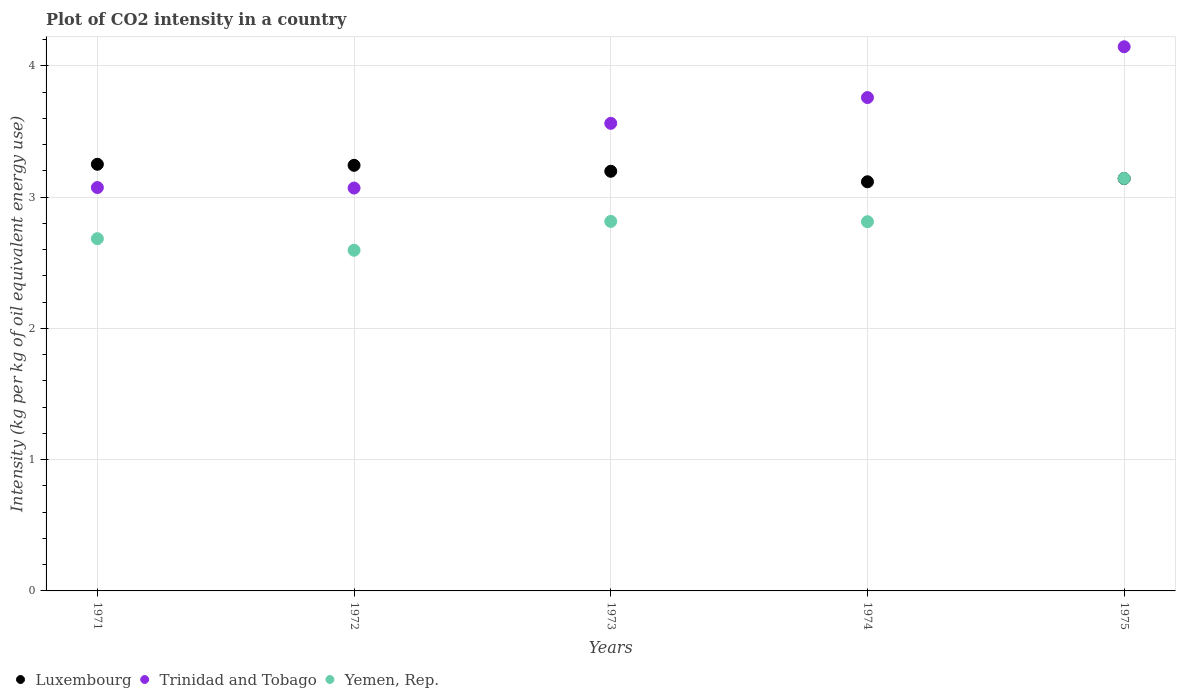How many different coloured dotlines are there?
Your answer should be compact. 3. Is the number of dotlines equal to the number of legend labels?
Make the answer very short. Yes. What is the CO2 intensity in in Yemen, Rep. in 1974?
Your response must be concise. 2.81. Across all years, what is the maximum CO2 intensity in in Trinidad and Tobago?
Offer a very short reply. 4.15. Across all years, what is the minimum CO2 intensity in in Luxembourg?
Offer a very short reply. 3.12. In which year was the CO2 intensity in in Luxembourg maximum?
Provide a succinct answer. 1971. In which year was the CO2 intensity in in Luxembourg minimum?
Provide a succinct answer. 1974. What is the total CO2 intensity in in Yemen, Rep. in the graph?
Provide a short and direct response. 14.05. What is the difference between the CO2 intensity in in Luxembourg in 1972 and that in 1975?
Provide a short and direct response. 0.1. What is the difference between the CO2 intensity in in Trinidad and Tobago in 1973 and the CO2 intensity in in Yemen, Rep. in 1972?
Make the answer very short. 0.97. What is the average CO2 intensity in in Luxembourg per year?
Keep it short and to the point. 3.19. In the year 1973, what is the difference between the CO2 intensity in in Trinidad and Tobago and CO2 intensity in in Luxembourg?
Make the answer very short. 0.37. In how many years, is the CO2 intensity in in Trinidad and Tobago greater than 3 kg?
Offer a terse response. 5. What is the ratio of the CO2 intensity in in Luxembourg in 1973 to that in 1974?
Keep it short and to the point. 1.03. What is the difference between the highest and the second highest CO2 intensity in in Trinidad and Tobago?
Provide a short and direct response. 0.39. What is the difference between the highest and the lowest CO2 intensity in in Yemen, Rep.?
Your answer should be very brief. 0.55. In how many years, is the CO2 intensity in in Luxembourg greater than the average CO2 intensity in in Luxembourg taken over all years?
Keep it short and to the point. 3. Does the CO2 intensity in in Trinidad and Tobago monotonically increase over the years?
Offer a terse response. No. What is the difference between two consecutive major ticks on the Y-axis?
Keep it short and to the point. 1. Are the values on the major ticks of Y-axis written in scientific E-notation?
Offer a terse response. No. Does the graph contain grids?
Provide a short and direct response. Yes. Where does the legend appear in the graph?
Give a very brief answer. Bottom left. How are the legend labels stacked?
Give a very brief answer. Horizontal. What is the title of the graph?
Your answer should be very brief. Plot of CO2 intensity in a country. What is the label or title of the X-axis?
Keep it short and to the point. Years. What is the label or title of the Y-axis?
Provide a short and direct response. Intensity (kg per kg of oil equivalent energy use). What is the Intensity (kg per kg of oil equivalent energy use) in Luxembourg in 1971?
Keep it short and to the point. 3.25. What is the Intensity (kg per kg of oil equivalent energy use) of Trinidad and Tobago in 1971?
Provide a short and direct response. 3.07. What is the Intensity (kg per kg of oil equivalent energy use) of Yemen, Rep. in 1971?
Offer a terse response. 2.68. What is the Intensity (kg per kg of oil equivalent energy use) in Luxembourg in 1972?
Your answer should be very brief. 3.24. What is the Intensity (kg per kg of oil equivalent energy use) of Trinidad and Tobago in 1972?
Give a very brief answer. 3.07. What is the Intensity (kg per kg of oil equivalent energy use) in Yemen, Rep. in 1972?
Provide a short and direct response. 2.6. What is the Intensity (kg per kg of oil equivalent energy use) in Luxembourg in 1973?
Make the answer very short. 3.2. What is the Intensity (kg per kg of oil equivalent energy use) in Trinidad and Tobago in 1973?
Offer a very short reply. 3.56. What is the Intensity (kg per kg of oil equivalent energy use) in Yemen, Rep. in 1973?
Keep it short and to the point. 2.81. What is the Intensity (kg per kg of oil equivalent energy use) in Luxembourg in 1974?
Ensure brevity in your answer.  3.12. What is the Intensity (kg per kg of oil equivalent energy use) of Trinidad and Tobago in 1974?
Your response must be concise. 3.76. What is the Intensity (kg per kg of oil equivalent energy use) in Yemen, Rep. in 1974?
Your answer should be very brief. 2.81. What is the Intensity (kg per kg of oil equivalent energy use) in Luxembourg in 1975?
Provide a short and direct response. 3.14. What is the Intensity (kg per kg of oil equivalent energy use) in Trinidad and Tobago in 1975?
Your response must be concise. 4.15. What is the Intensity (kg per kg of oil equivalent energy use) in Yemen, Rep. in 1975?
Your answer should be very brief. 3.14. Across all years, what is the maximum Intensity (kg per kg of oil equivalent energy use) of Luxembourg?
Your answer should be very brief. 3.25. Across all years, what is the maximum Intensity (kg per kg of oil equivalent energy use) in Trinidad and Tobago?
Offer a terse response. 4.15. Across all years, what is the maximum Intensity (kg per kg of oil equivalent energy use) of Yemen, Rep.?
Provide a short and direct response. 3.14. Across all years, what is the minimum Intensity (kg per kg of oil equivalent energy use) in Luxembourg?
Your response must be concise. 3.12. Across all years, what is the minimum Intensity (kg per kg of oil equivalent energy use) in Trinidad and Tobago?
Your answer should be very brief. 3.07. Across all years, what is the minimum Intensity (kg per kg of oil equivalent energy use) of Yemen, Rep.?
Make the answer very short. 2.6. What is the total Intensity (kg per kg of oil equivalent energy use) of Luxembourg in the graph?
Offer a terse response. 15.95. What is the total Intensity (kg per kg of oil equivalent energy use) in Trinidad and Tobago in the graph?
Your answer should be compact. 17.61. What is the total Intensity (kg per kg of oil equivalent energy use) in Yemen, Rep. in the graph?
Keep it short and to the point. 14.05. What is the difference between the Intensity (kg per kg of oil equivalent energy use) of Luxembourg in 1971 and that in 1972?
Give a very brief answer. 0.01. What is the difference between the Intensity (kg per kg of oil equivalent energy use) in Trinidad and Tobago in 1971 and that in 1972?
Your response must be concise. 0. What is the difference between the Intensity (kg per kg of oil equivalent energy use) in Yemen, Rep. in 1971 and that in 1972?
Keep it short and to the point. 0.09. What is the difference between the Intensity (kg per kg of oil equivalent energy use) of Luxembourg in 1971 and that in 1973?
Your response must be concise. 0.05. What is the difference between the Intensity (kg per kg of oil equivalent energy use) in Trinidad and Tobago in 1971 and that in 1973?
Give a very brief answer. -0.49. What is the difference between the Intensity (kg per kg of oil equivalent energy use) of Yemen, Rep. in 1971 and that in 1973?
Your answer should be compact. -0.13. What is the difference between the Intensity (kg per kg of oil equivalent energy use) in Luxembourg in 1971 and that in 1974?
Make the answer very short. 0.13. What is the difference between the Intensity (kg per kg of oil equivalent energy use) in Trinidad and Tobago in 1971 and that in 1974?
Offer a terse response. -0.69. What is the difference between the Intensity (kg per kg of oil equivalent energy use) in Yemen, Rep. in 1971 and that in 1974?
Keep it short and to the point. -0.13. What is the difference between the Intensity (kg per kg of oil equivalent energy use) in Luxembourg in 1971 and that in 1975?
Offer a terse response. 0.11. What is the difference between the Intensity (kg per kg of oil equivalent energy use) of Trinidad and Tobago in 1971 and that in 1975?
Make the answer very short. -1.07. What is the difference between the Intensity (kg per kg of oil equivalent energy use) of Yemen, Rep. in 1971 and that in 1975?
Ensure brevity in your answer.  -0.46. What is the difference between the Intensity (kg per kg of oil equivalent energy use) of Luxembourg in 1972 and that in 1973?
Give a very brief answer. 0.05. What is the difference between the Intensity (kg per kg of oil equivalent energy use) in Trinidad and Tobago in 1972 and that in 1973?
Offer a terse response. -0.49. What is the difference between the Intensity (kg per kg of oil equivalent energy use) in Yemen, Rep. in 1972 and that in 1973?
Your answer should be very brief. -0.22. What is the difference between the Intensity (kg per kg of oil equivalent energy use) of Luxembourg in 1972 and that in 1974?
Provide a short and direct response. 0.13. What is the difference between the Intensity (kg per kg of oil equivalent energy use) of Trinidad and Tobago in 1972 and that in 1974?
Ensure brevity in your answer.  -0.69. What is the difference between the Intensity (kg per kg of oil equivalent energy use) in Yemen, Rep. in 1972 and that in 1974?
Your response must be concise. -0.22. What is the difference between the Intensity (kg per kg of oil equivalent energy use) in Luxembourg in 1972 and that in 1975?
Your response must be concise. 0.1. What is the difference between the Intensity (kg per kg of oil equivalent energy use) of Trinidad and Tobago in 1972 and that in 1975?
Ensure brevity in your answer.  -1.08. What is the difference between the Intensity (kg per kg of oil equivalent energy use) of Yemen, Rep. in 1972 and that in 1975?
Keep it short and to the point. -0.55. What is the difference between the Intensity (kg per kg of oil equivalent energy use) in Trinidad and Tobago in 1973 and that in 1974?
Provide a succinct answer. -0.2. What is the difference between the Intensity (kg per kg of oil equivalent energy use) in Yemen, Rep. in 1973 and that in 1974?
Your answer should be compact. 0. What is the difference between the Intensity (kg per kg of oil equivalent energy use) of Luxembourg in 1973 and that in 1975?
Your answer should be compact. 0.06. What is the difference between the Intensity (kg per kg of oil equivalent energy use) in Trinidad and Tobago in 1973 and that in 1975?
Offer a very short reply. -0.58. What is the difference between the Intensity (kg per kg of oil equivalent energy use) in Yemen, Rep. in 1973 and that in 1975?
Offer a very short reply. -0.33. What is the difference between the Intensity (kg per kg of oil equivalent energy use) in Luxembourg in 1974 and that in 1975?
Your answer should be compact. -0.02. What is the difference between the Intensity (kg per kg of oil equivalent energy use) in Trinidad and Tobago in 1974 and that in 1975?
Offer a very short reply. -0.39. What is the difference between the Intensity (kg per kg of oil equivalent energy use) of Yemen, Rep. in 1974 and that in 1975?
Your answer should be very brief. -0.33. What is the difference between the Intensity (kg per kg of oil equivalent energy use) of Luxembourg in 1971 and the Intensity (kg per kg of oil equivalent energy use) of Trinidad and Tobago in 1972?
Ensure brevity in your answer.  0.18. What is the difference between the Intensity (kg per kg of oil equivalent energy use) of Luxembourg in 1971 and the Intensity (kg per kg of oil equivalent energy use) of Yemen, Rep. in 1972?
Provide a short and direct response. 0.65. What is the difference between the Intensity (kg per kg of oil equivalent energy use) in Trinidad and Tobago in 1971 and the Intensity (kg per kg of oil equivalent energy use) in Yemen, Rep. in 1972?
Make the answer very short. 0.48. What is the difference between the Intensity (kg per kg of oil equivalent energy use) of Luxembourg in 1971 and the Intensity (kg per kg of oil equivalent energy use) of Trinidad and Tobago in 1973?
Make the answer very short. -0.31. What is the difference between the Intensity (kg per kg of oil equivalent energy use) in Luxembourg in 1971 and the Intensity (kg per kg of oil equivalent energy use) in Yemen, Rep. in 1973?
Your answer should be compact. 0.44. What is the difference between the Intensity (kg per kg of oil equivalent energy use) of Trinidad and Tobago in 1971 and the Intensity (kg per kg of oil equivalent energy use) of Yemen, Rep. in 1973?
Give a very brief answer. 0.26. What is the difference between the Intensity (kg per kg of oil equivalent energy use) of Luxembourg in 1971 and the Intensity (kg per kg of oil equivalent energy use) of Trinidad and Tobago in 1974?
Make the answer very short. -0.51. What is the difference between the Intensity (kg per kg of oil equivalent energy use) in Luxembourg in 1971 and the Intensity (kg per kg of oil equivalent energy use) in Yemen, Rep. in 1974?
Ensure brevity in your answer.  0.44. What is the difference between the Intensity (kg per kg of oil equivalent energy use) of Trinidad and Tobago in 1971 and the Intensity (kg per kg of oil equivalent energy use) of Yemen, Rep. in 1974?
Your response must be concise. 0.26. What is the difference between the Intensity (kg per kg of oil equivalent energy use) in Luxembourg in 1971 and the Intensity (kg per kg of oil equivalent energy use) in Trinidad and Tobago in 1975?
Provide a succinct answer. -0.9. What is the difference between the Intensity (kg per kg of oil equivalent energy use) of Luxembourg in 1971 and the Intensity (kg per kg of oil equivalent energy use) of Yemen, Rep. in 1975?
Your answer should be very brief. 0.11. What is the difference between the Intensity (kg per kg of oil equivalent energy use) of Trinidad and Tobago in 1971 and the Intensity (kg per kg of oil equivalent energy use) of Yemen, Rep. in 1975?
Make the answer very short. -0.07. What is the difference between the Intensity (kg per kg of oil equivalent energy use) of Luxembourg in 1972 and the Intensity (kg per kg of oil equivalent energy use) of Trinidad and Tobago in 1973?
Offer a terse response. -0.32. What is the difference between the Intensity (kg per kg of oil equivalent energy use) of Luxembourg in 1972 and the Intensity (kg per kg of oil equivalent energy use) of Yemen, Rep. in 1973?
Provide a short and direct response. 0.43. What is the difference between the Intensity (kg per kg of oil equivalent energy use) in Trinidad and Tobago in 1972 and the Intensity (kg per kg of oil equivalent energy use) in Yemen, Rep. in 1973?
Ensure brevity in your answer.  0.25. What is the difference between the Intensity (kg per kg of oil equivalent energy use) of Luxembourg in 1972 and the Intensity (kg per kg of oil equivalent energy use) of Trinidad and Tobago in 1974?
Ensure brevity in your answer.  -0.52. What is the difference between the Intensity (kg per kg of oil equivalent energy use) in Luxembourg in 1972 and the Intensity (kg per kg of oil equivalent energy use) in Yemen, Rep. in 1974?
Offer a very short reply. 0.43. What is the difference between the Intensity (kg per kg of oil equivalent energy use) in Trinidad and Tobago in 1972 and the Intensity (kg per kg of oil equivalent energy use) in Yemen, Rep. in 1974?
Your answer should be very brief. 0.26. What is the difference between the Intensity (kg per kg of oil equivalent energy use) in Luxembourg in 1972 and the Intensity (kg per kg of oil equivalent energy use) in Trinidad and Tobago in 1975?
Make the answer very short. -0.9. What is the difference between the Intensity (kg per kg of oil equivalent energy use) of Luxembourg in 1972 and the Intensity (kg per kg of oil equivalent energy use) of Yemen, Rep. in 1975?
Keep it short and to the point. 0.1. What is the difference between the Intensity (kg per kg of oil equivalent energy use) of Trinidad and Tobago in 1972 and the Intensity (kg per kg of oil equivalent energy use) of Yemen, Rep. in 1975?
Give a very brief answer. -0.07. What is the difference between the Intensity (kg per kg of oil equivalent energy use) in Luxembourg in 1973 and the Intensity (kg per kg of oil equivalent energy use) in Trinidad and Tobago in 1974?
Ensure brevity in your answer.  -0.56. What is the difference between the Intensity (kg per kg of oil equivalent energy use) in Luxembourg in 1973 and the Intensity (kg per kg of oil equivalent energy use) in Yemen, Rep. in 1974?
Give a very brief answer. 0.38. What is the difference between the Intensity (kg per kg of oil equivalent energy use) in Trinidad and Tobago in 1973 and the Intensity (kg per kg of oil equivalent energy use) in Yemen, Rep. in 1974?
Ensure brevity in your answer.  0.75. What is the difference between the Intensity (kg per kg of oil equivalent energy use) of Luxembourg in 1973 and the Intensity (kg per kg of oil equivalent energy use) of Trinidad and Tobago in 1975?
Your answer should be compact. -0.95. What is the difference between the Intensity (kg per kg of oil equivalent energy use) in Luxembourg in 1973 and the Intensity (kg per kg of oil equivalent energy use) in Yemen, Rep. in 1975?
Give a very brief answer. 0.05. What is the difference between the Intensity (kg per kg of oil equivalent energy use) in Trinidad and Tobago in 1973 and the Intensity (kg per kg of oil equivalent energy use) in Yemen, Rep. in 1975?
Provide a short and direct response. 0.42. What is the difference between the Intensity (kg per kg of oil equivalent energy use) of Luxembourg in 1974 and the Intensity (kg per kg of oil equivalent energy use) of Trinidad and Tobago in 1975?
Give a very brief answer. -1.03. What is the difference between the Intensity (kg per kg of oil equivalent energy use) of Luxembourg in 1974 and the Intensity (kg per kg of oil equivalent energy use) of Yemen, Rep. in 1975?
Provide a short and direct response. -0.03. What is the difference between the Intensity (kg per kg of oil equivalent energy use) in Trinidad and Tobago in 1974 and the Intensity (kg per kg of oil equivalent energy use) in Yemen, Rep. in 1975?
Your answer should be very brief. 0.62. What is the average Intensity (kg per kg of oil equivalent energy use) in Luxembourg per year?
Give a very brief answer. 3.19. What is the average Intensity (kg per kg of oil equivalent energy use) in Trinidad and Tobago per year?
Provide a short and direct response. 3.52. What is the average Intensity (kg per kg of oil equivalent energy use) in Yemen, Rep. per year?
Make the answer very short. 2.81. In the year 1971, what is the difference between the Intensity (kg per kg of oil equivalent energy use) of Luxembourg and Intensity (kg per kg of oil equivalent energy use) of Trinidad and Tobago?
Provide a succinct answer. 0.18. In the year 1971, what is the difference between the Intensity (kg per kg of oil equivalent energy use) of Luxembourg and Intensity (kg per kg of oil equivalent energy use) of Yemen, Rep.?
Keep it short and to the point. 0.57. In the year 1971, what is the difference between the Intensity (kg per kg of oil equivalent energy use) in Trinidad and Tobago and Intensity (kg per kg of oil equivalent energy use) in Yemen, Rep.?
Provide a succinct answer. 0.39. In the year 1972, what is the difference between the Intensity (kg per kg of oil equivalent energy use) in Luxembourg and Intensity (kg per kg of oil equivalent energy use) in Trinidad and Tobago?
Your answer should be very brief. 0.17. In the year 1972, what is the difference between the Intensity (kg per kg of oil equivalent energy use) in Luxembourg and Intensity (kg per kg of oil equivalent energy use) in Yemen, Rep.?
Your answer should be compact. 0.65. In the year 1972, what is the difference between the Intensity (kg per kg of oil equivalent energy use) of Trinidad and Tobago and Intensity (kg per kg of oil equivalent energy use) of Yemen, Rep.?
Keep it short and to the point. 0.47. In the year 1973, what is the difference between the Intensity (kg per kg of oil equivalent energy use) of Luxembourg and Intensity (kg per kg of oil equivalent energy use) of Trinidad and Tobago?
Your answer should be compact. -0.37. In the year 1973, what is the difference between the Intensity (kg per kg of oil equivalent energy use) of Luxembourg and Intensity (kg per kg of oil equivalent energy use) of Yemen, Rep.?
Provide a short and direct response. 0.38. In the year 1973, what is the difference between the Intensity (kg per kg of oil equivalent energy use) in Trinidad and Tobago and Intensity (kg per kg of oil equivalent energy use) in Yemen, Rep.?
Make the answer very short. 0.75. In the year 1974, what is the difference between the Intensity (kg per kg of oil equivalent energy use) in Luxembourg and Intensity (kg per kg of oil equivalent energy use) in Trinidad and Tobago?
Provide a short and direct response. -0.64. In the year 1974, what is the difference between the Intensity (kg per kg of oil equivalent energy use) of Luxembourg and Intensity (kg per kg of oil equivalent energy use) of Yemen, Rep.?
Keep it short and to the point. 0.3. In the year 1974, what is the difference between the Intensity (kg per kg of oil equivalent energy use) of Trinidad and Tobago and Intensity (kg per kg of oil equivalent energy use) of Yemen, Rep.?
Offer a terse response. 0.95. In the year 1975, what is the difference between the Intensity (kg per kg of oil equivalent energy use) of Luxembourg and Intensity (kg per kg of oil equivalent energy use) of Trinidad and Tobago?
Offer a terse response. -1. In the year 1975, what is the difference between the Intensity (kg per kg of oil equivalent energy use) of Luxembourg and Intensity (kg per kg of oil equivalent energy use) of Yemen, Rep.?
Make the answer very short. -0. What is the ratio of the Intensity (kg per kg of oil equivalent energy use) of Yemen, Rep. in 1971 to that in 1972?
Ensure brevity in your answer.  1.03. What is the ratio of the Intensity (kg per kg of oil equivalent energy use) in Luxembourg in 1971 to that in 1973?
Your answer should be compact. 1.02. What is the ratio of the Intensity (kg per kg of oil equivalent energy use) of Trinidad and Tobago in 1971 to that in 1973?
Ensure brevity in your answer.  0.86. What is the ratio of the Intensity (kg per kg of oil equivalent energy use) in Yemen, Rep. in 1971 to that in 1973?
Give a very brief answer. 0.95. What is the ratio of the Intensity (kg per kg of oil equivalent energy use) of Luxembourg in 1971 to that in 1974?
Offer a very short reply. 1.04. What is the ratio of the Intensity (kg per kg of oil equivalent energy use) in Trinidad and Tobago in 1971 to that in 1974?
Offer a terse response. 0.82. What is the ratio of the Intensity (kg per kg of oil equivalent energy use) in Yemen, Rep. in 1971 to that in 1974?
Provide a succinct answer. 0.95. What is the ratio of the Intensity (kg per kg of oil equivalent energy use) of Luxembourg in 1971 to that in 1975?
Ensure brevity in your answer.  1.03. What is the ratio of the Intensity (kg per kg of oil equivalent energy use) of Trinidad and Tobago in 1971 to that in 1975?
Provide a short and direct response. 0.74. What is the ratio of the Intensity (kg per kg of oil equivalent energy use) of Yemen, Rep. in 1971 to that in 1975?
Keep it short and to the point. 0.85. What is the ratio of the Intensity (kg per kg of oil equivalent energy use) in Luxembourg in 1972 to that in 1973?
Provide a short and direct response. 1.01. What is the ratio of the Intensity (kg per kg of oil equivalent energy use) of Trinidad and Tobago in 1972 to that in 1973?
Provide a succinct answer. 0.86. What is the ratio of the Intensity (kg per kg of oil equivalent energy use) in Yemen, Rep. in 1972 to that in 1973?
Your response must be concise. 0.92. What is the ratio of the Intensity (kg per kg of oil equivalent energy use) in Luxembourg in 1972 to that in 1974?
Offer a very short reply. 1.04. What is the ratio of the Intensity (kg per kg of oil equivalent energy use) in Trinidad and Tobago in 1972 to that in 1974?
Your answer should be compact. 0.82. What is the ratio of the Intensity (kg per kg of oil equivalent energy use) of Yemen, Rep. in 1972 to that in 1974?
Make the answer very short. 0.92. What is the ratio of the Intensity (kg per kg of oil equivalent energy use) of Luxembourg in 1972 to that in 1975?
Provide a succinct answer. 1.03. What is the ratio of the Intensity (kg per kg of oil equivalent energy use) in Trinidad and Tobago in 1972 to that in 1975?
Provide a short and direct response. 0.74. What is the ratio of the Intensity (kg per kg of oil equivalent energy use) in Yemen, Rep. in 1972 to that in 1975?
Offer a very short reply. 0.83. What is the ratio of the Intensity (kg per kg of oil equivalent energy use) in Luxembourg in 1973 to that in 1974?
Keep it short and to the point. 1.03. What is the ratio of the Intensity (kg per kg of oil equivalent energy use) in Trinidad and Tobago in 1973 to that in 1974?
Ensure brevity in your answer.  0.95. What is the ratio of the Intensity (kg per kg of oil equivalent energy use) in Yemen, Rep. in 1973 to that in 1974?
Ensure brevity in your answer.  1. What is the ratio of the Intensity (kg per kg of oil equivalent energy use) in Luxembourg in 1973 to that in 1975?
Your answer should be compact. 1.02. What is the ratio of the Intensity (kg per kg of oil equivalent energy use) of Trinidad and Tobago in 1973 to that in 1975?
Offer a very short reply. 0.86. What is the ratio of the Intensity (kg per kg of oil equivalent energy use) of Yemen, Rep. in 1973 to that in 1975?
Keep it short and to the point. 0.9. What is the ratio of the Intensity (kg per kg of oil equivalent energy use) in Trinidad and Tobago in 1974 to that in 1975?
Provide a short and direct response. 0.91. What is the ratio of the Intensity (kg per kg of oil equivalent energy use) of Yemen, Rep. in 1974 to that in 1975?
Provide a short and direct response. 0.9. What is the difference between the highest and the second highest Intensity (kg per kg of oil equivalent energy use) in Luxembourg?
Your answer should be compact. 0.01. What is the difference between the highest and the second highest Intensity (kg per kg of oil equivalent energy use) of Trinidad and Tobago?
Your response must be concise. 0.39. What is the difference between the highest and the second highest Intensity (kg per kg of oil equivalent energy use) of Yemen, Rep.?
Ensure brevity in your answer.  0.33. What is the difference between the highest and the lowest Intensity (kg per kg of oil equivalent energy use) of Luxembourg?
Offer a very short reply. 0.13. What is the difference between the highest and the lowest Intensity (kg per kg of oil equivalent energy use) in Trinidad and Tobago?
Your response must be concise. 1.08. What is the difference between the highest and the lowest Intensity (kg per kg of oil equivalent energy use) in Yemen, Rep.?
Give a very brief answer. 0.55. 